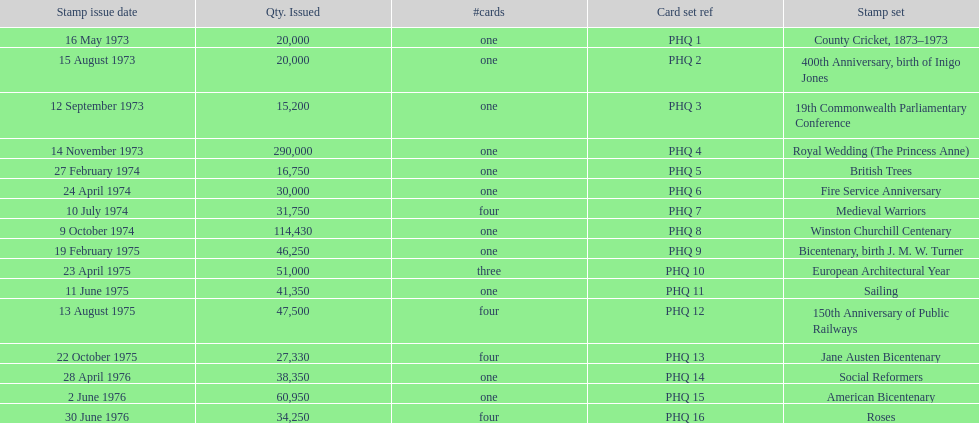Which stamp set had only three cards in the set? European Architectural Year. 